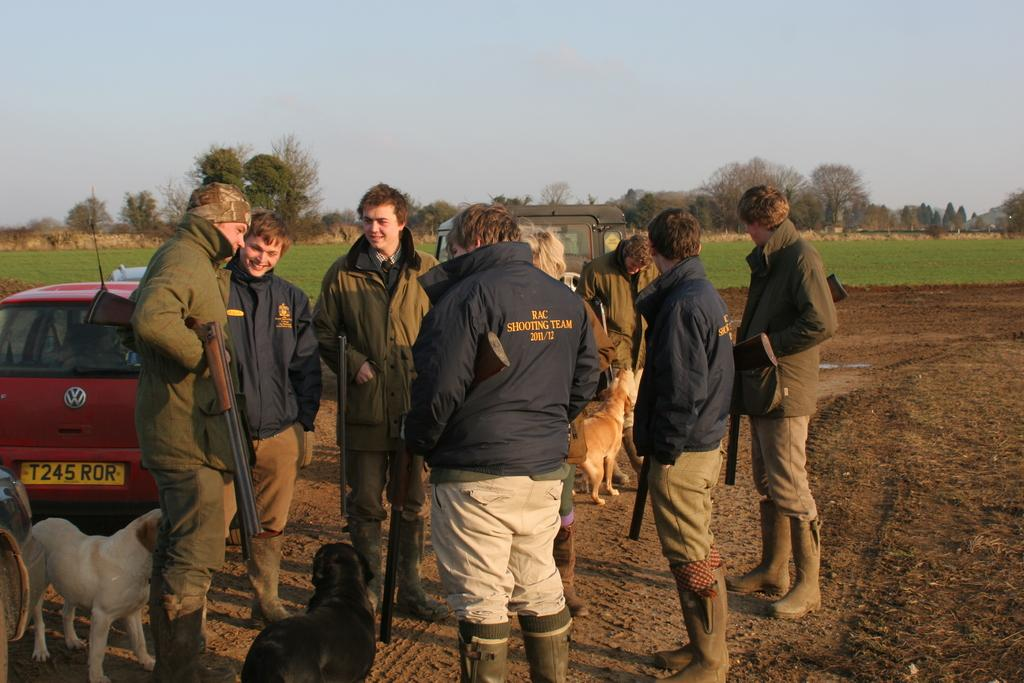How many people are in the group visible in the image? There is a group of people in the image, but the exact number is not specified. What are some of the people in the group holding? Some people in the group are carrying rifles. What animals are present in the image? There are dogs in the image. What type of vehicle is in the image? There is a car in the image. What type of vegetation is present in the image? Trees and plants are present in the image. What type of peace offering is being made by the person holding the eggs in the image? There are no eggs present in the image, so it is not possible to answer that question. 